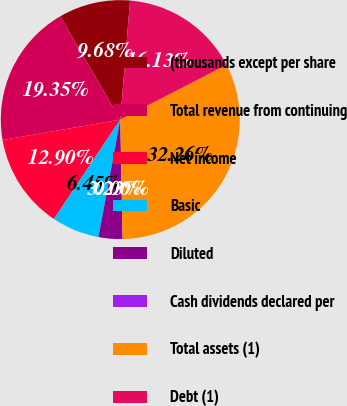<chart> <loc_0><loc_0><loc_500><loc_500><pie_chart><fcel>(thousands except per share<fcel>Total revenue from continuing<fcel>Net income<fcel>Basic<fcel>Diluted<fcel>Cash dividends declared per<fcel>Total assets (1)<fcel>Debt (1)<nl><fcel>9.68%<fcel>19.35%<fcel>12.9%<fcel>6.45%<fcel>3.23%<fcel>0.0%<fcel>32.26%<fcel>16.13%<nl></chart> 